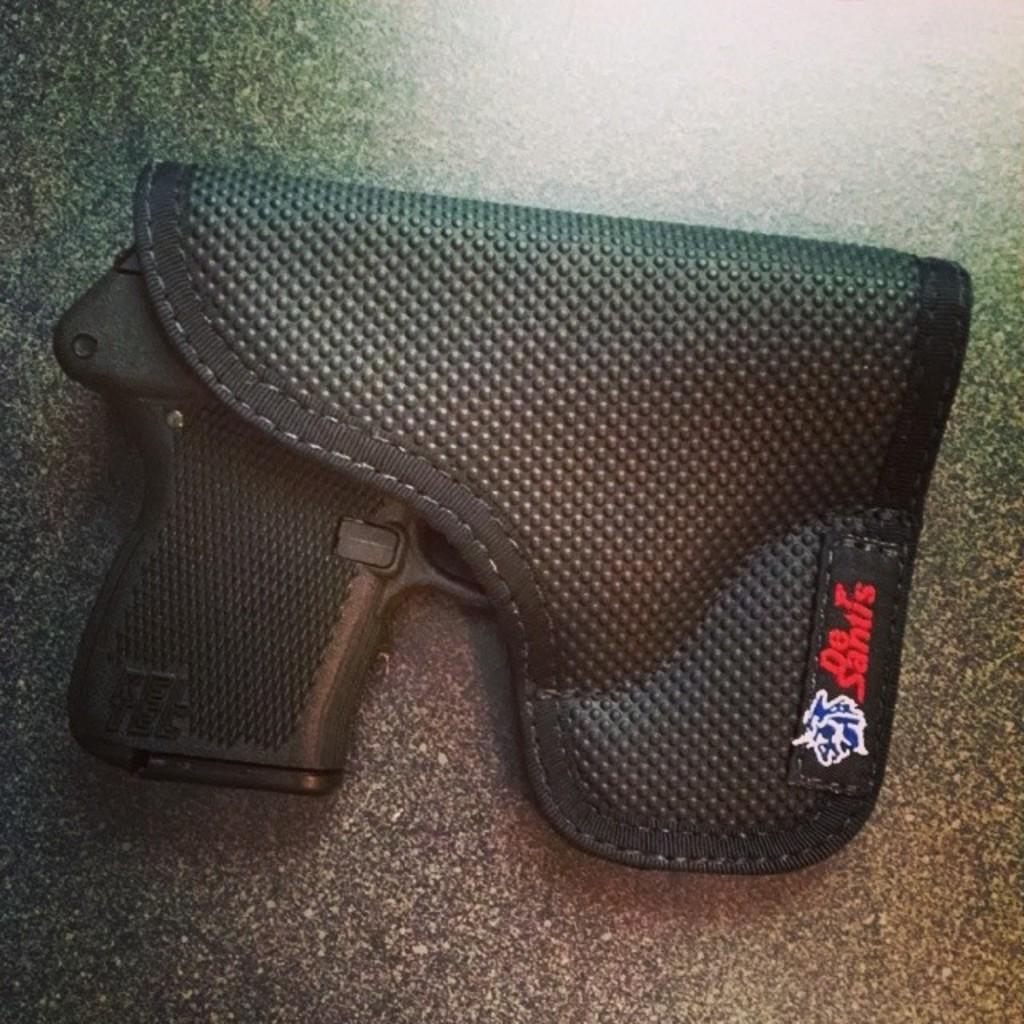Could you give a brief overview of what you see in this image? In this image we can see a gun placed in a case on the surface. 